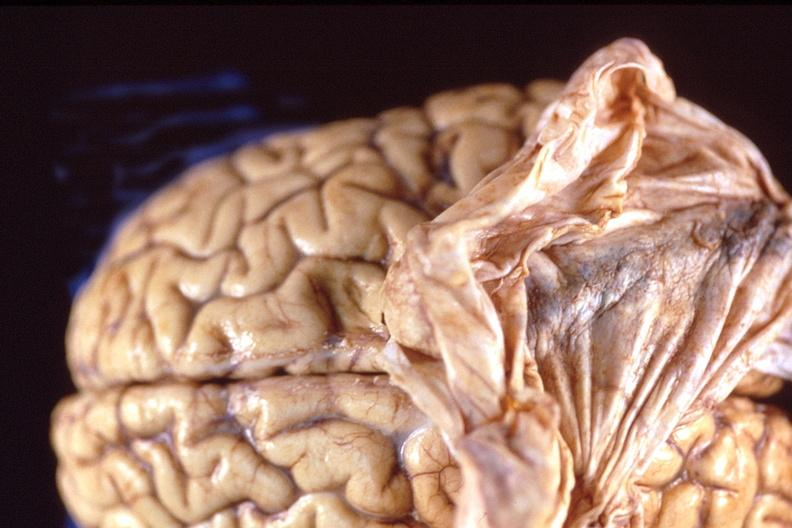what does this image show?
Answer the question using a single word or phrase. Brain 